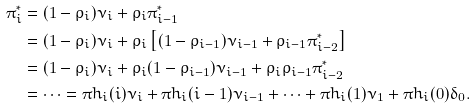Convert formula to latex. <formula><loc_0><loc_0><loc_500><loc_500>\pi ^ { * } _ { i } & = ( 1 - \rho _ { i } ) \nu _ { i } + \rho _ { i } \pi ^ { * } _ { i - 1 } \\ & = ( 1 - \rho _ { i } ) \nu _ { i } + \rho _ { i } \left [ ( 1 - \rho _ { i - 1 } ) \nu _ { i - 1 } + \rho _ { i - 1 } \pi ^ { * } _ { i - 2 } \right ] \\ & = ( 1 - \rho _ { i } ) \nu _ { i } + \rho _ { i } ( 1 - \rho _ { i - 1 } ) \nu _ { i - 1 } + \rho _ { i } \rho _ { i - 1 } \pi ^ { * } _ { i - 2 } \\ & = \cdots = \pi h _ { i } ( i ) \nu _ { i } + \pi h _ { i } ( i - 1 ) \nu _ { i - 1 } + \cdots + \pi h _ { i } ( 1 ) \nu _ { 1 } + \pi h _ { i } ( 0 ) \delta _ { 0 } .</formula> 